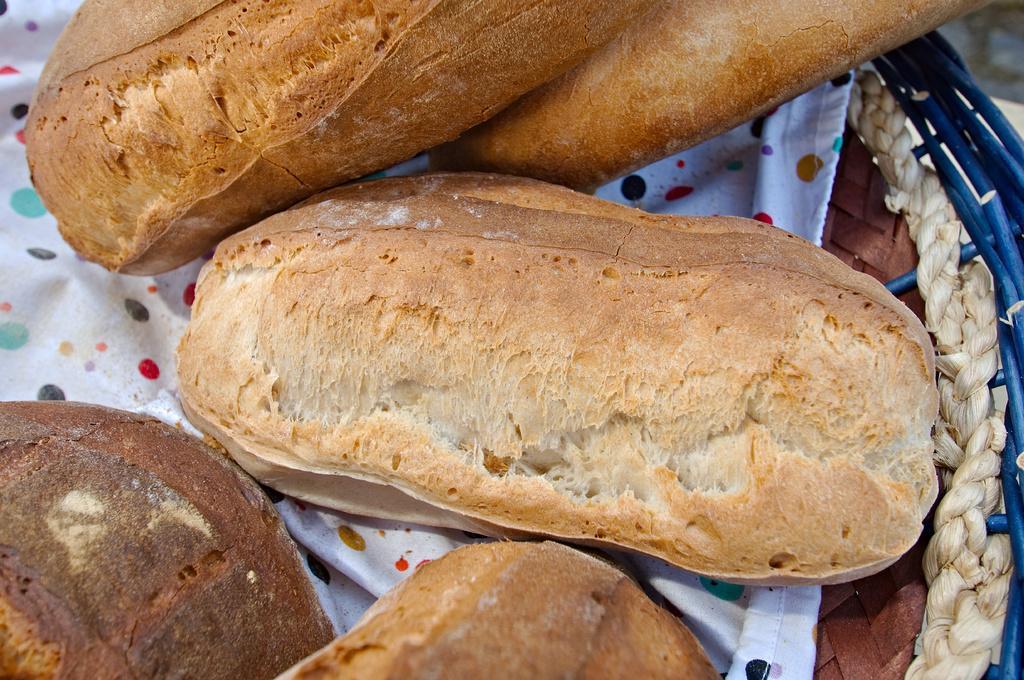Describe this image in one or two sentences. In this picture we can observe some food places in the basket. There is a white color cloth here. The food is looking like buns. 